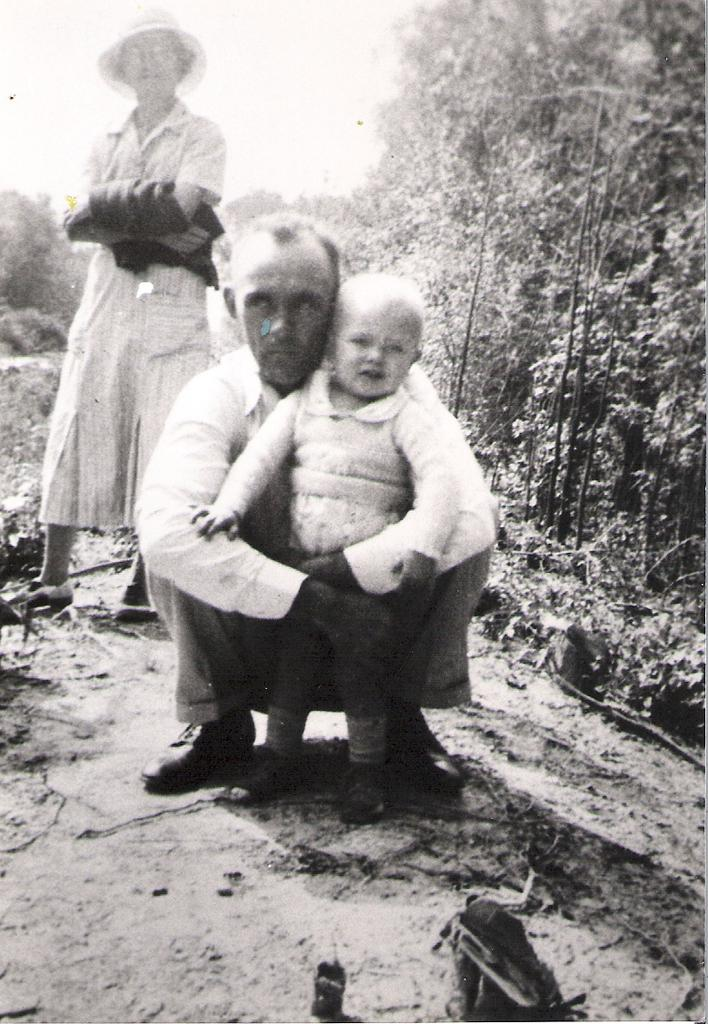Who or what can be seen in the image? There are people in the image. What can be seen in the distance behind the people? There are trees in the background of the image. How much sugar is present in the image? There is no mention of sugar in the image, so it cannot be determined from the image. 